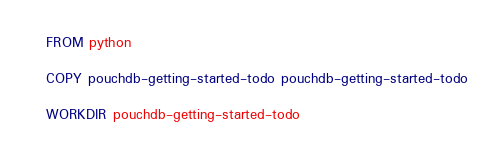Convert code to text. <code><loc_0><loc_0><loc_500><loc_500><_Dockerfile_>FROM python

COPY pouchdb-getting-started-todo pouchdb-getting-started-todo

WORKDIR pouchdb-getting-started-todo


</code> 